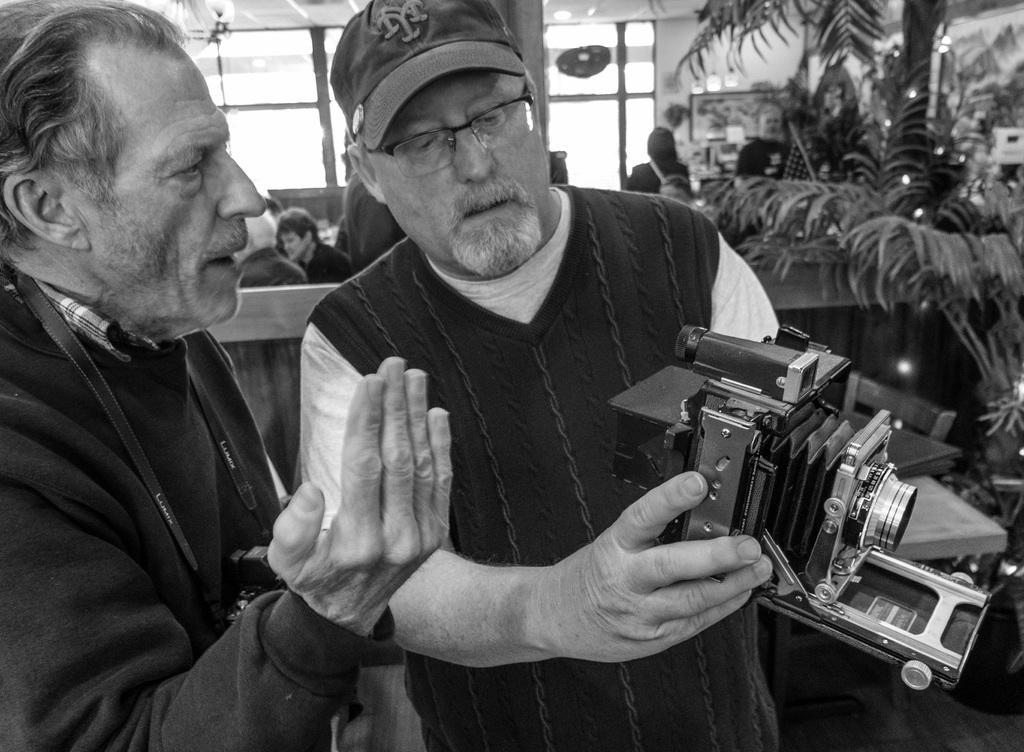Could you give a brief overview of what you see in this image? In this image we can see two old persons are standing and one is holding a camera in his hands. In the background we can see three, persons and glass window. 